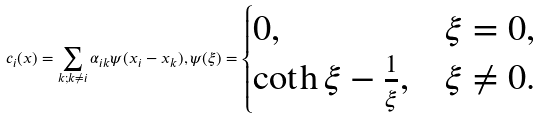<formula> <loc_0><loc_0><loc_500><loc_500>c _ { i } ( x ) = \sum _ { k ; k \neq i } \alpha _ { i k } \psi ( x _ { i } - x _ { k } ) , \psi ( \xi ) = \begin{cases} 0 , & \xi = 0 , \\ \coth \xi - \frac { 1 } \xi , & \xi \neq 0 . \end{cases}</formula> 